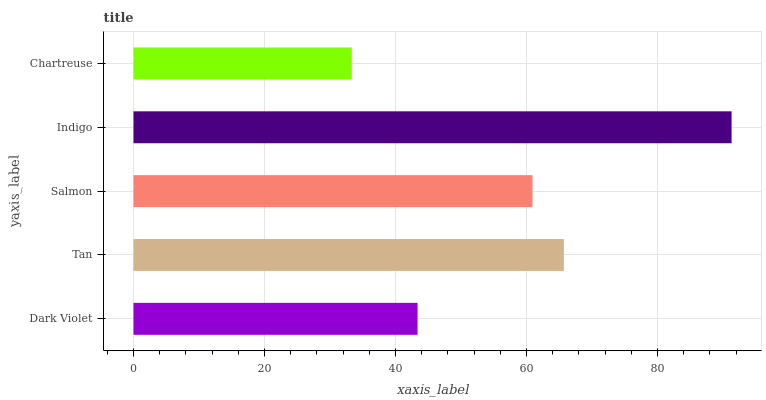Is Chartreuse the minimum?
Answer yes or no. Yes. Is Indigo the maximum?
Answer yes or no. Yes. Is Tan the minimum?
Answer yes or no. No. Is Tan the maximum?
Answer yes or no. No. Is Tan greater than Dark Violet?
Answer yes or no. Yes. Is Dark Violet less than Tan?
Answer yes or no. Yes. Is Dark Violet greater than Tan?
Answer yes or no. No. Is Tan less than Dark Violet?
Answer yes or no. No. Is Salmon the high median?
Answer yes or no. Yes. Is Salmon the low median?
Answer yes or no. Yes. Is Chartreuse the high median?
Answer yes or no. No. Is Tan the low median?
Answer yes or no. No. 